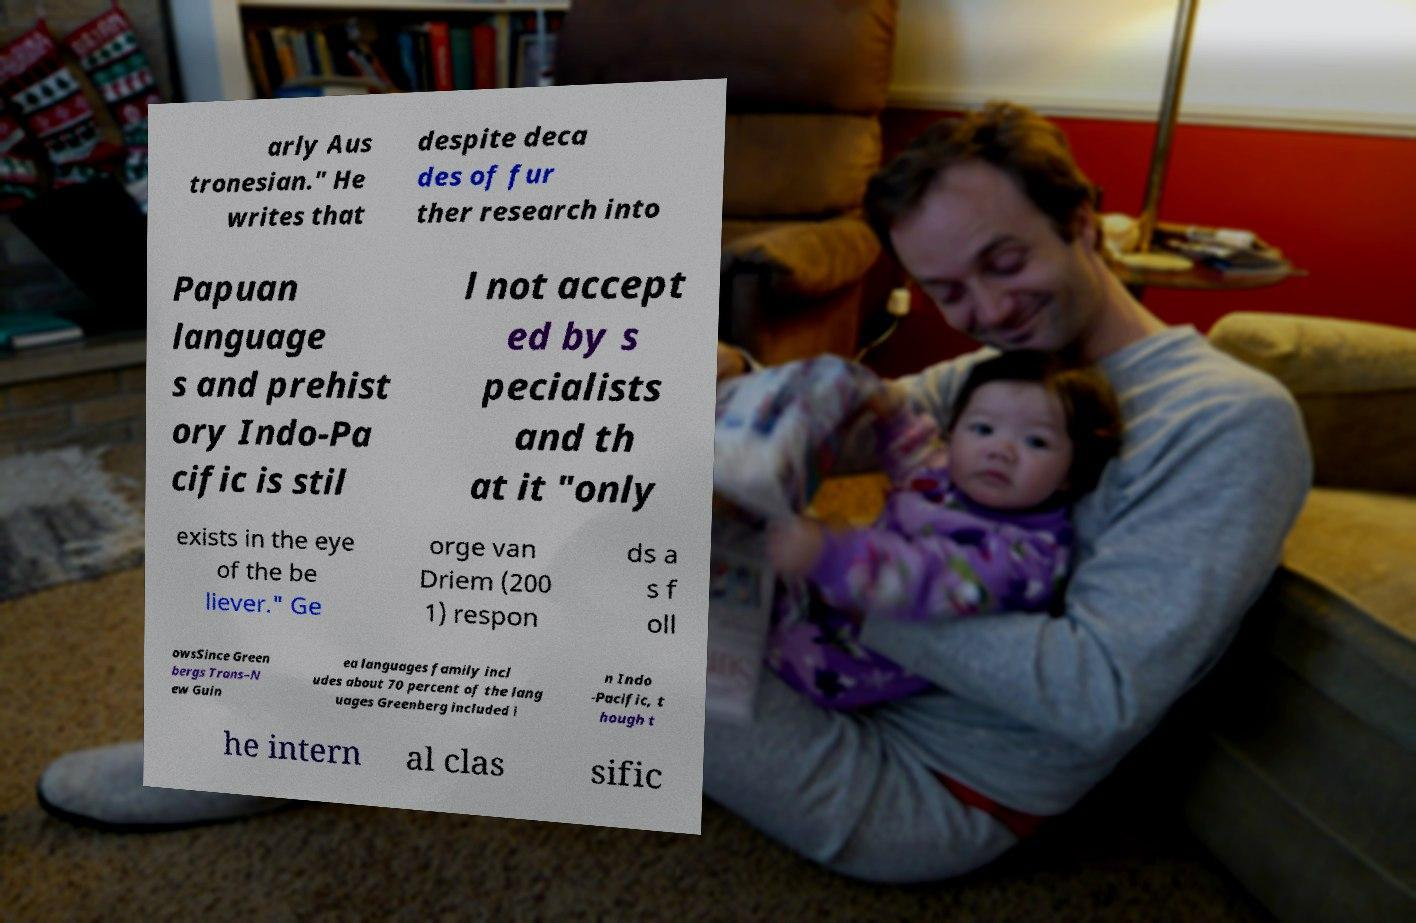I need the written content from this picture converted into text. Can you do that? arly Aus tronesian." He writes that despite deca des of fur ther research into Papuan language s and prehist ory Indo-Pa cific is stil l not accept ed by s pecialists and th at it "only exists in the eye of the be liever." Ge orge van Driem (200 1) respon ds a s f oll owsSince Green bergs Trans–N ew Guin ea languages family incl udes about 70 percent of the lang uages Greenberg included i n Indo -Pacific, t hough t he intern al clas sific 